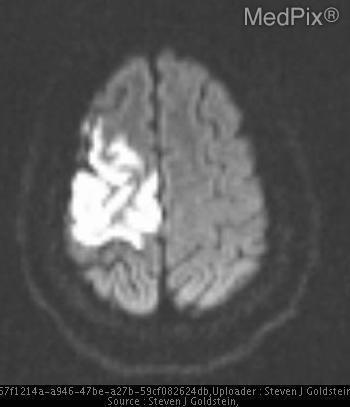What is the hyperdensity in the image?
Short answer required. Infarct. What lobe is the infarct in?
Answer briefly. Right parietal. Which lobe is infarcted
Give a very brief answer. Right parietal. Is there a subarachnoid bleed in the image?
Give a very brief answer. No. Is a subarachnoid bleed present?
Keep it brief. No. Are the cortexes atrophied here?
Quick response, please. No. Is cortical atrophy present?
Write a very short answer. No. 